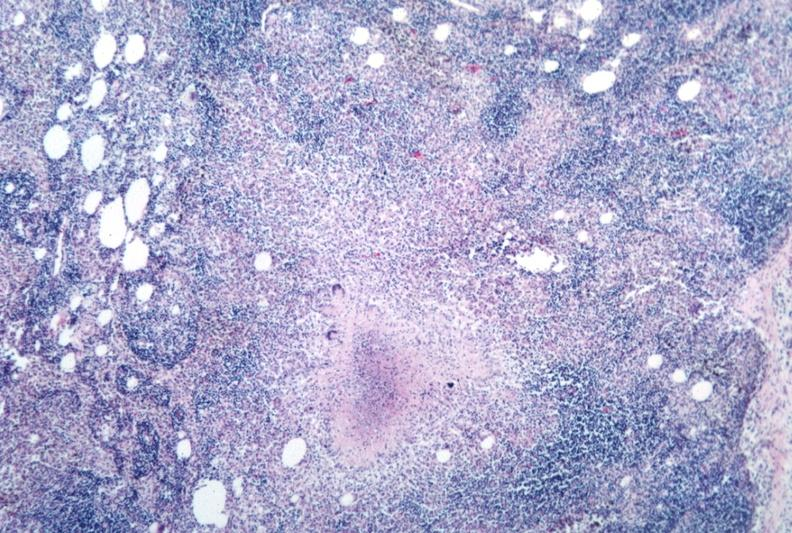what does this image show?
Answer the question using a single word or phrase. Necrotizing granuloma 